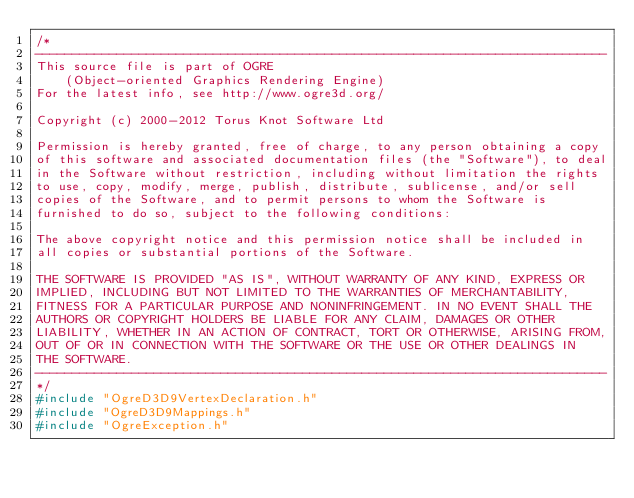Convert code to text. <code><loc_0><loc_0><loc_500><loc_500><_C++_>/*
-----------------------------------------------------------------------------
This source file is part of OGRE
    (Object-oriented Graphics Rendering Engine)
For the latest info, see http://www.ogre3d.org/

Copyright (c) 2000-2012 Torus Knot Software Ltd

Permission is hereby granted, free of charge, to any person obtaining a copy
of this software and associated documentation files (the "Software"), to deal
in the Software without restriction, including without limitation the rights
to use, copy, modify, merge, publish, distribute, sublicense, and/or sell
copies of the Software, and to permit persons to whom the Software is
furnished to do so, subject to the following conditions:

The above copyright notice and this permission notice shall be included in
all copies or substantial portions of the Software.

THE SOFTWARE IS PROVIDED "AS IS", WITHOUT WARRANTY OF ANY KIND, EXPRESS OR
IMPLIED, INCLUDING BUT NOT LIMITED TO THE WARRANTIES OF MERCHANTABILITY,
FITNESS FOR A PARTICULAR PURPOSE AND NONINFRINGEMENT. IN NO EVENT SHALL THE
AUTHORS OR COPYRIGHT HOLDERS BE LIABLE FOR ANY CLAIM, DAMAGES OR OTHER
LIABILITY, WHETHER IN AN ACTION OF CONTRACT, TORT OR OTHERWISE, ARISING FROM,
OUT OF OR IN CONNECTION WITH THE SOFTWARE OR THE USE OR OTHER DEALINGS IN
THE SOFTWARE.
-----------------------------------------------------------------------------
*/
#include "OgreD3D9VertexDeclaration.h"
#include "OgreD3D9Mappings.h"
#include "OgreException.h"</code> 